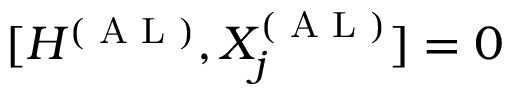<formula> <loc_0><loc_0><loc_500><loc_500>[ H ^ { ( A L ) } , X _ { j } ^ { ( A L ) } ] = 0</formula> 